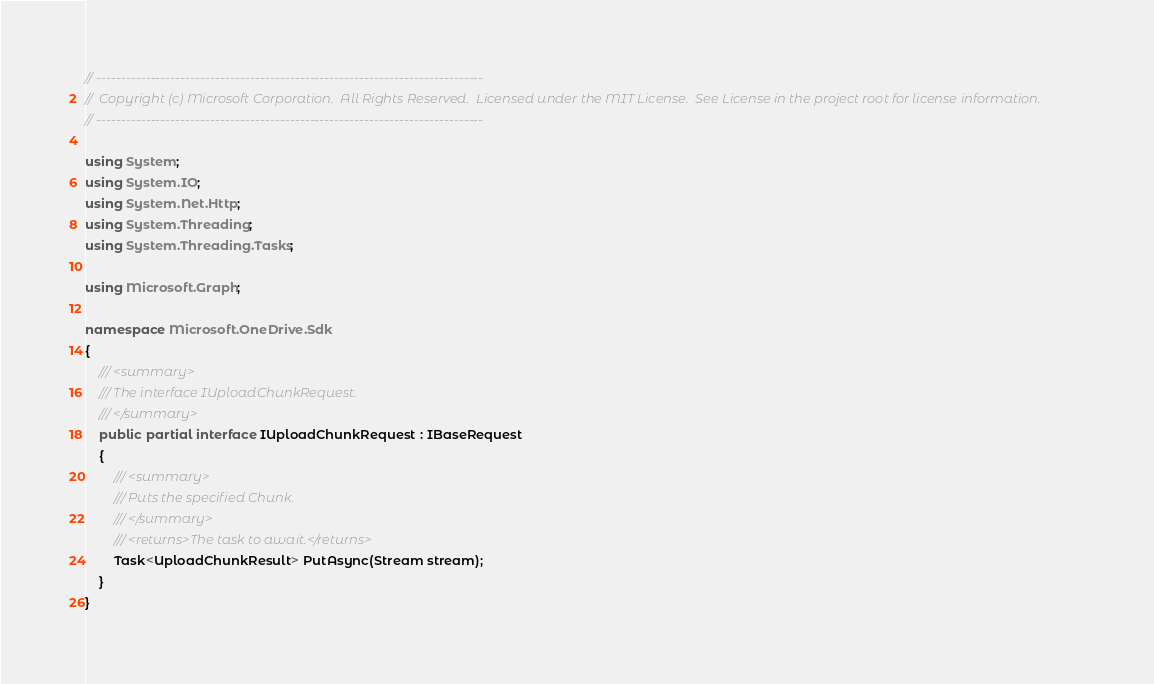Convert code to text. <code><loc_0><loc_0><loc_500><loc_500><_C#_>// ------------------------------------------------------------------------------
//  Copyright (c) Microsoft Corporation.  All Rights Reserved.  Licensed under the MIT License.  See License in the project root for license information.
// ------------------------------------------------------------------------------

using System;
using System.IO;
using System.Net.Http;
using System.Threading;
using System.Threading.Tasks;

using Microsoft.Graph;

namespace Microsoft.OneDrive.Sdk
{
    /// <summary>
    /// The interface IUploadChunkRequest.
    /// </summary>
    public partial interface IUploadChunkRequest : IBaseRequest
    {
        /// <summary>
        /// Puts the specified Chunk.
        /// </summary>
        /// <returns>The task to await.</returns>
        Task<UploadChunkResult> PutAsync(Stream stream);
    }
}
</code> 